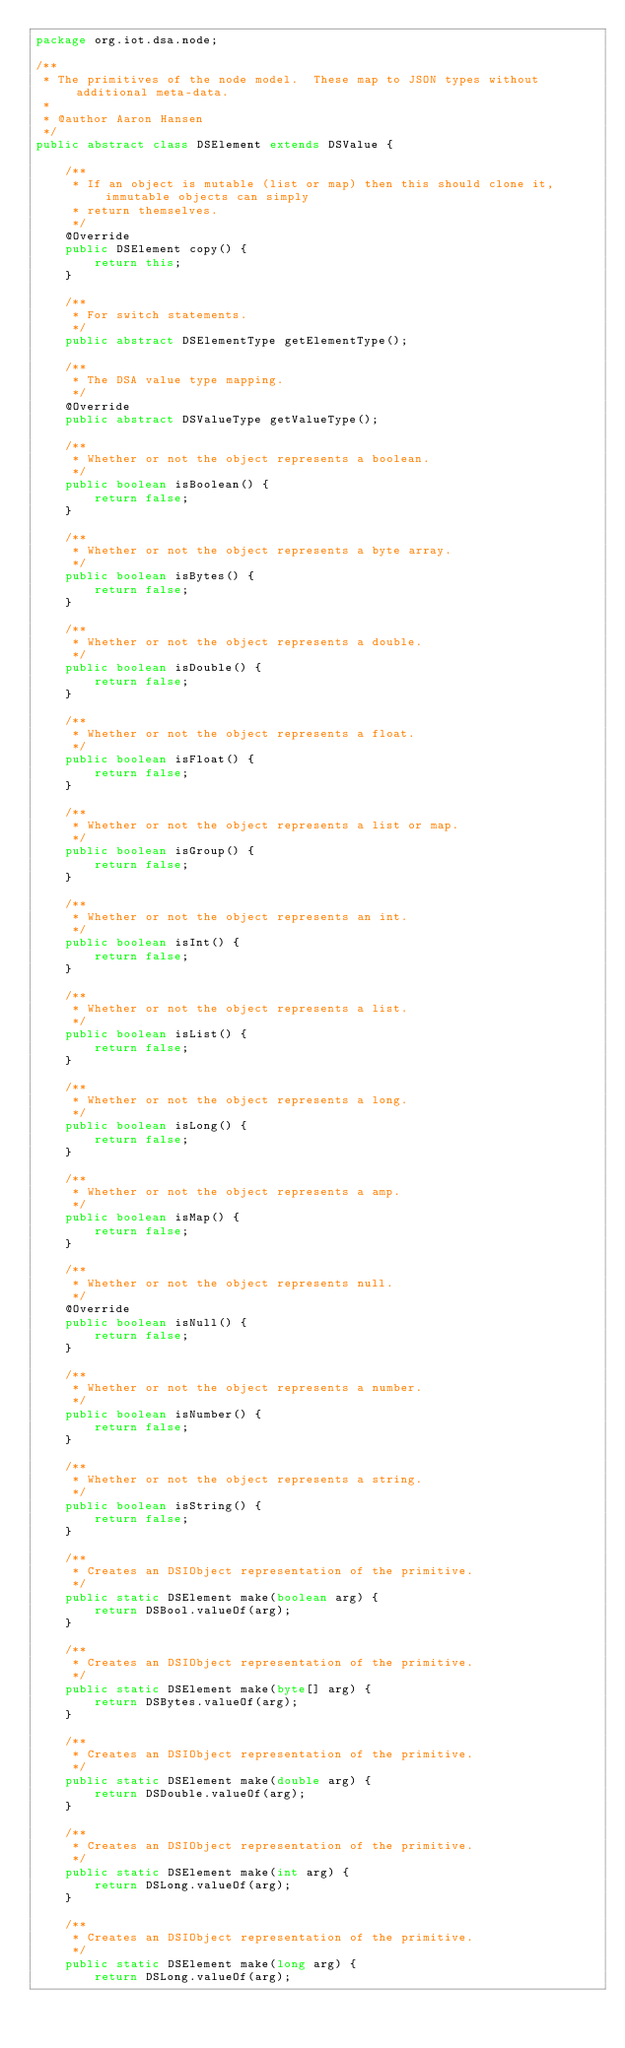<code> <loc_0><loc_0><loc_500><loc_500><_Java_>package org.iot.dsa.node;

/**
 * The primitives of the node model.  These map to JSON types without additional meta-data.
 *
 * @author Aaron Hansen
 */
public abstract class DSElement extends DSValue {

    /**
     * If an object is mutable (list or map) then this should clone it, immutable objects can simply
     * return themselves.
     */
    @Override
    public DSElement copy() {
        return this;
    }

    /**
     * For switch statements.
     */
    public abstract DSElementType getElementType();

    /**
     * The DSA value type mapping.
     */
    @Override
    public abstract DSValueType getValueType();

    /**
     * Whether or not the object represents a boolean.
     */
    public boolean isBoolean() {
        return false;
    }

    /**
     * Whether or not the object represents a byte array.
     */
    public boolean isBytes() {
        return false;
    }

    /**
     * Whether or not the object represents a double.
     */
    public boolean isDouble() {
        return false;
    }

    /**
     * Whether or not the object represents a float.
     */
    public boolean isFloat() {
        return false;
    }

    /**
     * Whether or not the object represents a list or map.
     */
    public boolean isGroup() {
        return false;
    }

    /**
     * Whether or not the object represents an int.
     */
    public boolean isInt() {
        return false;
    }

    /**
     * Whether or not the object represents a list.
     */
    public boolean isList() {
        return false;
    }

    /**
     * Whether or not the object represents a long.
     */
    public boolean isLong() {
        return false;
    }

    /**
     * Whether or not the object represents a amp.
     */
    public boolean isMap() {
        return false;
    }

    /**
     * Whether or not the object represents null.
     */
    @Override
    public boolean isNull() {
        return false;
    }

    /**
     * Whether or not the object represents a number.
     */
    public boolean isNumber() {
        return false;
    }

    /**
     * Whether or not the object represents a string.
     */
    public boolean isString() {
        return false;
    }

    /**
     * Creates an DSIObject representation of the primitive.
     */
    public static DSElement make(boolean arg) {
        return DSBool.valueOf(arg);
    }

    /**
     * Creates an DSIObject representation of the primitive.
     */
    public static DSElement make(byte[] arg) {
        return DSBytes.valueOf(arg);
    }

    /**
     * Creates an DSIObject representation of the primitive.
     */
    public static DSElement make(double arg) {
        return DSDouble.valueOf(arg);
    }

    /**
     * Creates an DSIObject representation of the primitive.
     */
    public static DSElement make(int arg) {
        return DSLong.valueOf(arg);
    }

    /**
     * Creates an DSIObject representation of the primitive.
     */
    public static DSElement make(long arg) {
        return DSLong.valueOf(arg);</code> 